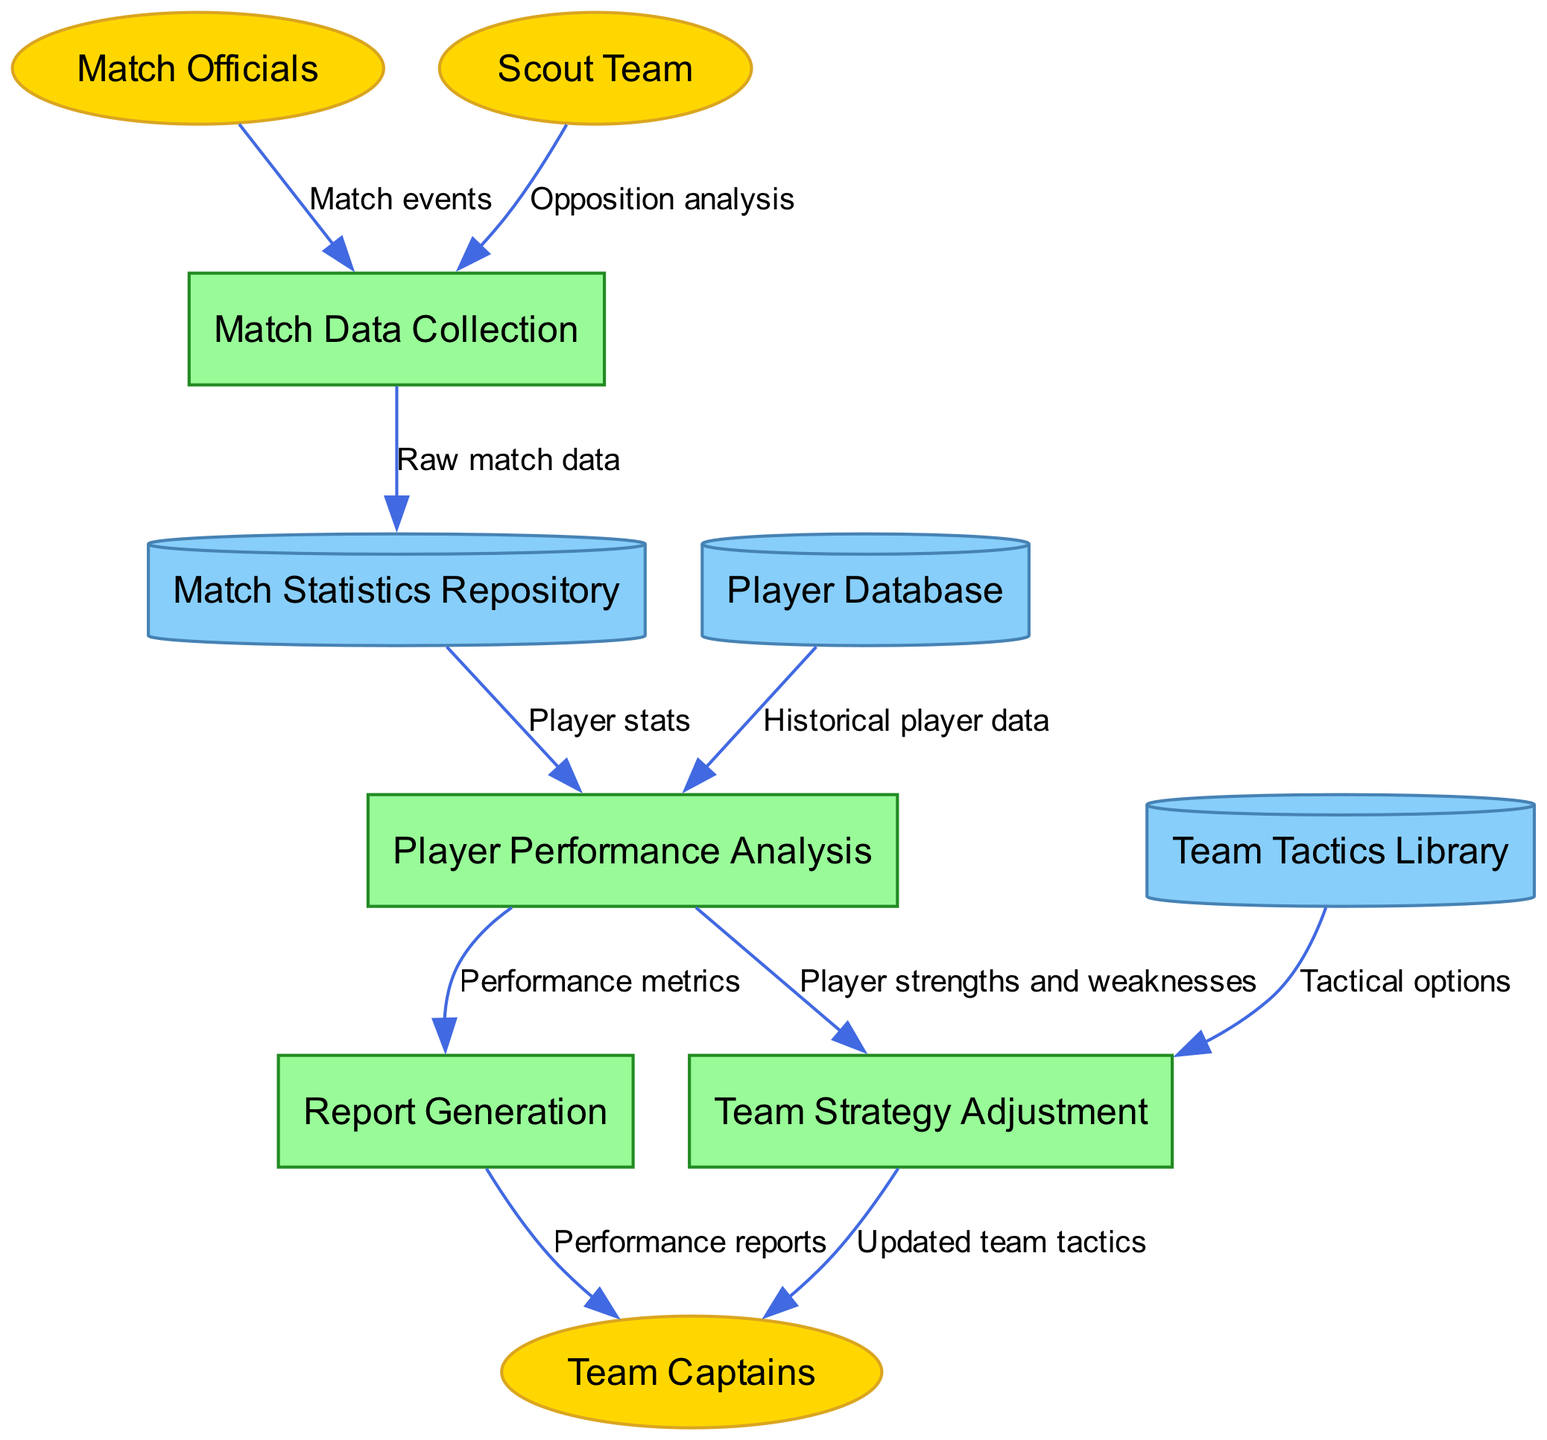What are the external entities in the diagram? The diagram lists three external entities: Match Officials, Scout Team, and Team Captains. These entities are shown as ellipses in the diagram, which represent the sources or destinations of data flows.
Answer: Match Officials, Scout Team, Team Captains How many processes are represented in the diagram? There are four processes in the diagram: Match Data Collection, Player Performance Analysis, Team Strategy Adjustment, and Report Generation. Each process is depicted as a rectangle and they perform specific functions in the system.
Answer: 4 What type of data store holds player stats? The Player Performance Analysis process receives Player stats from the Match Statistics Repository, which is a cylindrical data store. This shows that it is where match statistics are stored for analysis.
Answer: Match Statistics Repository Which process generates reports for the team captains? The Report Generation process provides Performance reports to the Team Captains. The flow indicates that this process is responsible for summarizing and reporting the analyzed performance metrics.
Answer: Report Generation What information is sent from the Player Database to Player Performance Analysis? The Player Performance Analysis process receives Historical player data from the Player Database. This involves past data related to players that informs their current performance evaluations.
Answer: Historical player data What is the main purpose of the Team Strategy Adjustment process? The main purpose is to utilize Tactical options from the Team Tactics Library and Player strengths and weaknesses from the Player Performance Analysis to update to Team Captains. This illustrates how strategies are adapted based on analysis and previous knowledge.
Answer: Update team tactics What flows from the Match Officials to the Match Data Collection process? The Match events flow from the Match Officials to the Match Data Collection process, as officials record key occurrences during a match that contribute to overall statistics collection.
Answer: Match events Which data flows into the Match Statistics Repository? The Raw match data flows from the Match Data Collection process into the Match Statistics Repository. This is where the collected data is stored for further analysis.
Answer: Raw match data What type of information does the Team Tactics Library provide? The Team Tactics Library provides Tactical options to the Team Strategy Adjustment process, indicating it contains strategies and formations that the team can utilize based on analyses.
Answer: Tactical options 